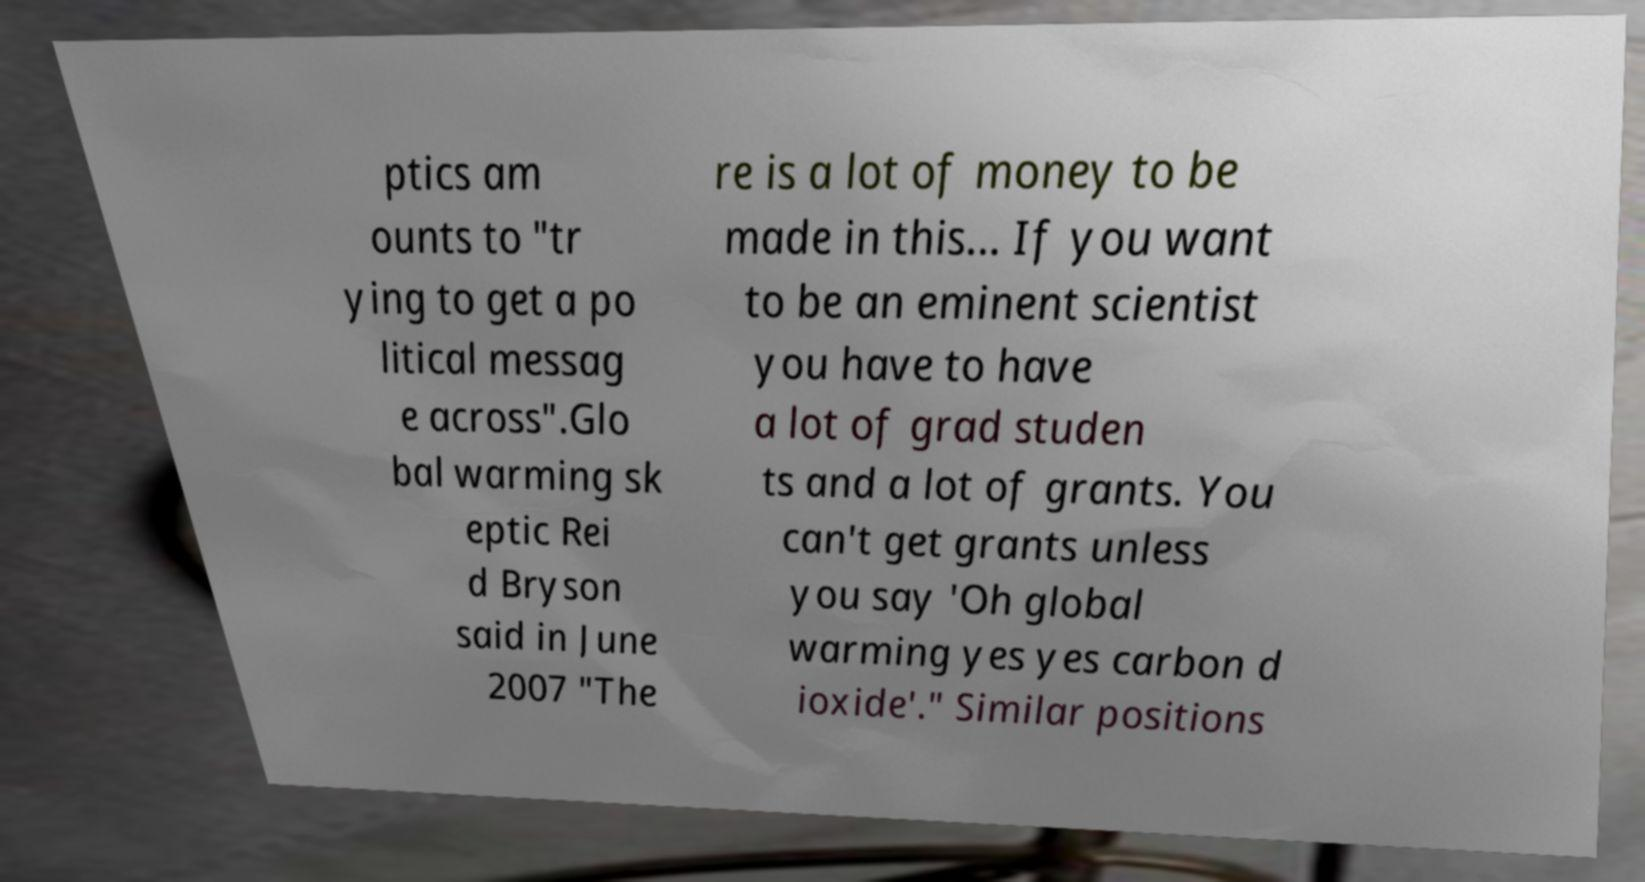Can you accurately transcribe the text from the provided image for me? ptics am ounts to "tr ying to get a po litical messag e across".Glo bal warming sk eptic Rei d Bryson said in June 2007 "The re is a lot of money to be made in this... If you want to be an eminent scientist you have to have a lot of grad studen ts and a lot of grants. You can't get grants unless you say 'Oh global warming yes yes carbon d ioxide'." Similar positions 